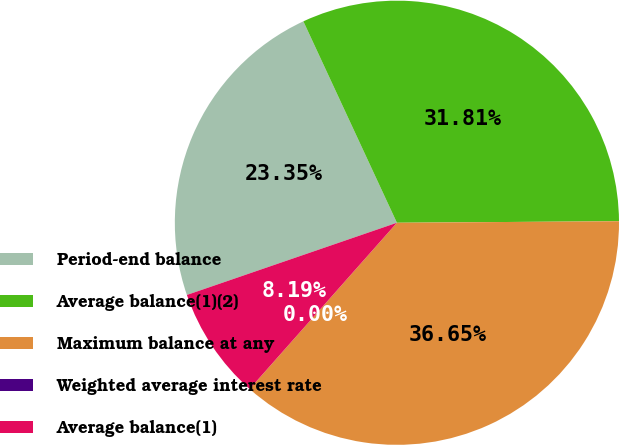<chart> <loc_0><loc_0><loc_500><loc_500><pie_chart><fcel>Period-end balance<fcel>Average balance(1)(2)<fcel>Maximum balance at any<fcel>Weighted average interest rate<fcel>Average balance(1)<nl><fcel>23.35%<fcel>31.81%<fcel>36.65%<fcel>0.0%<fcel>8.19%<nl></chart> 